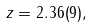<formula> <loc_0><loc_0><loc_500><loc_500>z = 2 . 3 6 ( 9 ) ,</formula> 